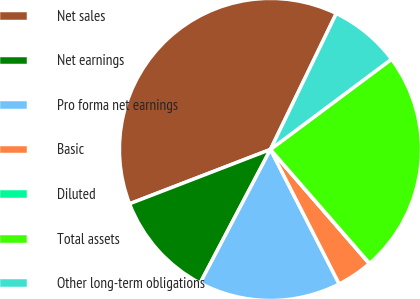Convert chart to OTSL. <chart><loc_0><loc_0><loc_500><loc_500><pie_chart><fcel>Net sales<fcel>Net earnings<fcel>Pro forma net earnings<fcel>Basic<fcel>Diluted<fcel>Total assets<fcel>Other long-term obligations<nl><fcel>38.03%<fcel>11.43%<fcel>15.23%<fcel>3.84%<fcel>0.04%<fcel>23.8%<fcel>7.63%<nl></chart> 